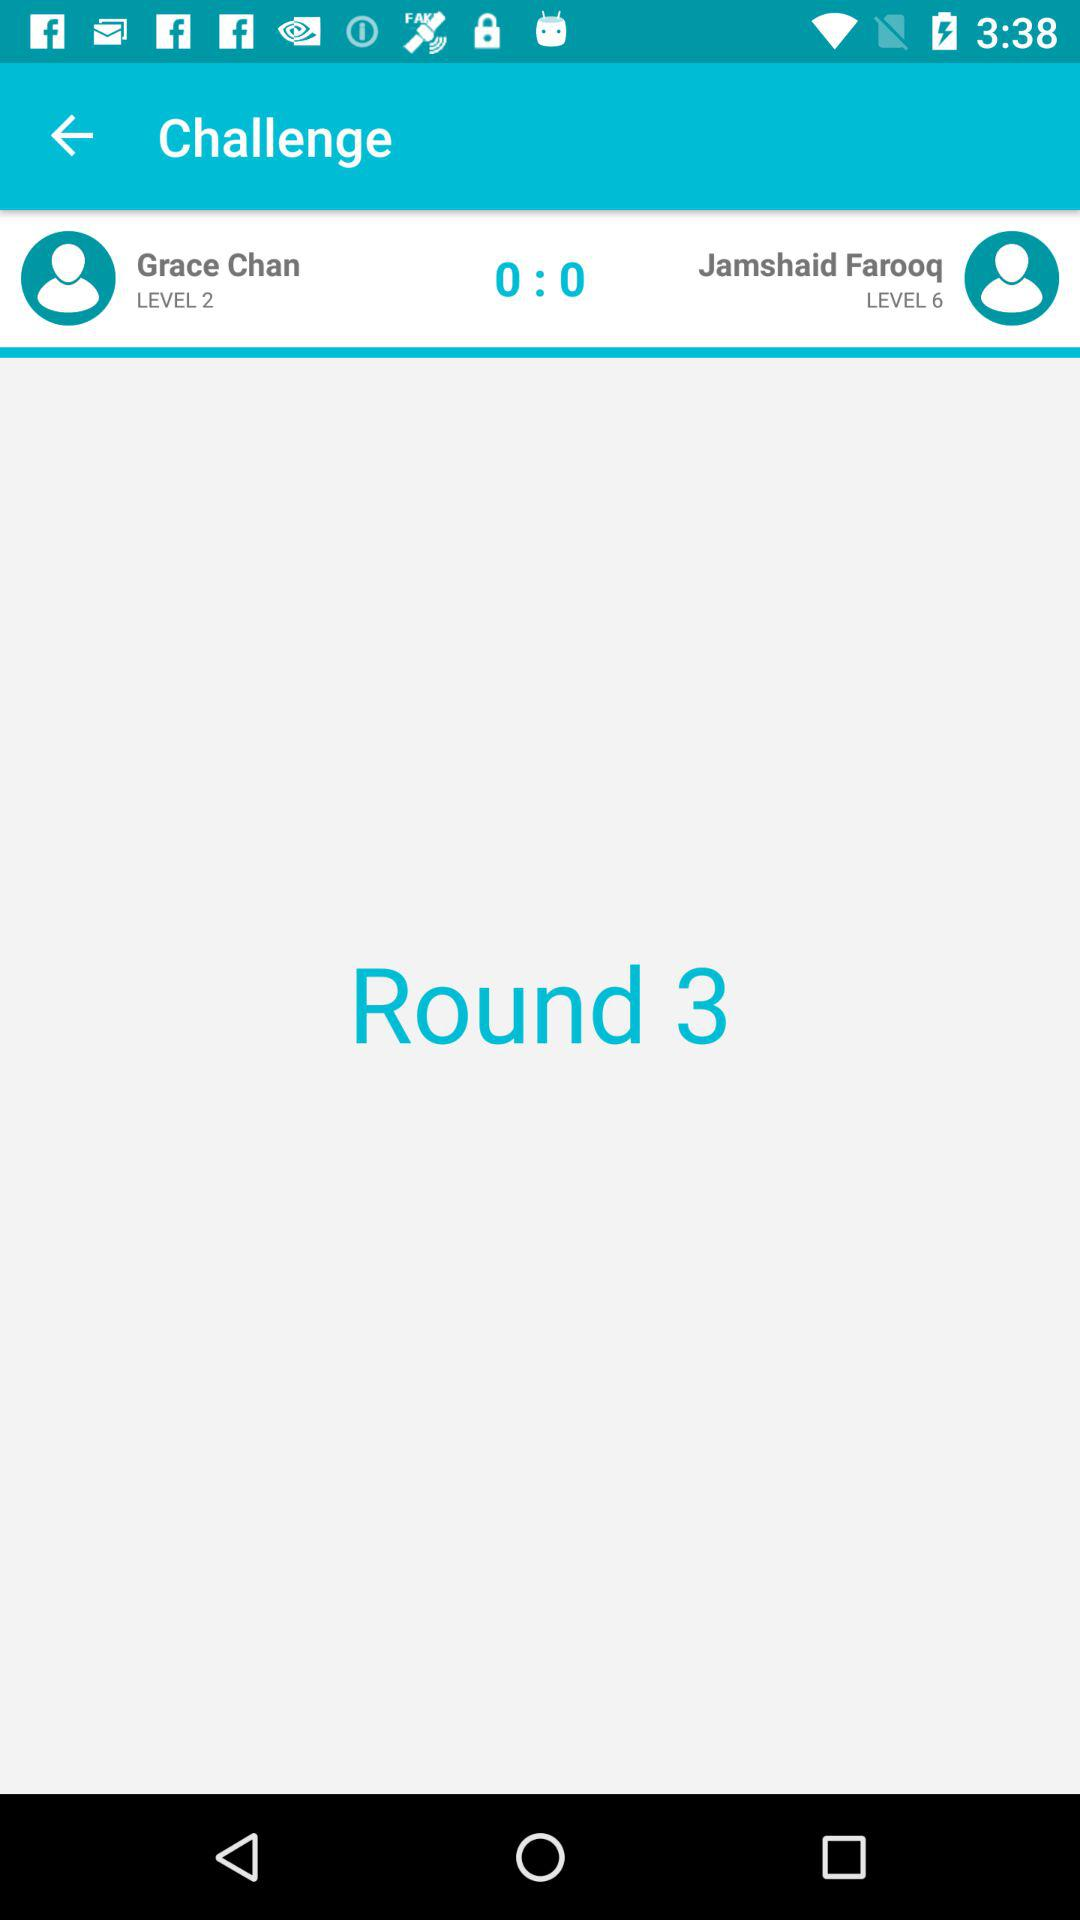Which round is on? It is round 3. 